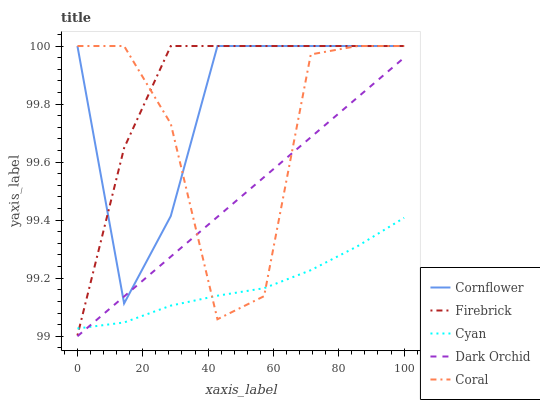Does Cyan have the minimum area under the curve?
Answer yes or no. Yes. Does Firebrick have the maximum area under the curve?
Answer yes or no. Yes. Does Coral have the minimum area under the curve?
Answer yes or no. No. Does Coral have the maximum area under the curve?
Answer yes or no. No. Is Dark Orchid the smoothest?
Answer yes or no. Yes. Is Coral the roughest?
Answer yes or no. Yes. Is Firebrick the smoothest?
Answer yes or no. No. Is Firebrick the roughest?
Answer yes or no. No. Does Dark Orchid have the lowest value?
Answer yes or no. Yes. Does Firebrick have the lowest value?
Answer yes or no. No. Does Coral have the highest value?
Answer yes or no. Yes. Does Dark Orchid have the highest value?
Answer yes or no. No. Is Dark Orchid less than Firebrick?
Answer yes or no. Yes. Is Firebrick greater than Dark Orchid?
Answer yes or no. Yes. Does Coral intersect Firebrick?
Answer yes or no. Yes. Is Coral less than Firebrick?
Answer yes or no. No. Is Coral greater than Firebrick?
Answer yes or no. No. Does Dark Orchid intersect Firebrick?
Answer yes or no. No. 